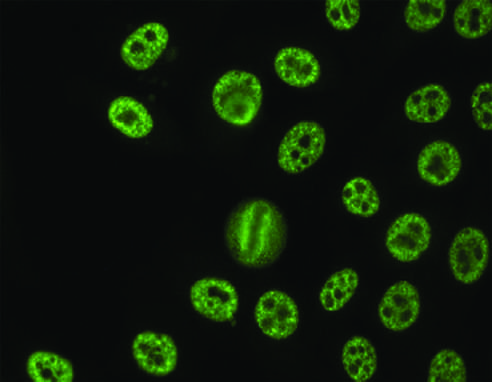s failure to stain seen with antibodies against various nuclear antigens, including sm and rnps?
Answer the question using a single word or phrase. No 